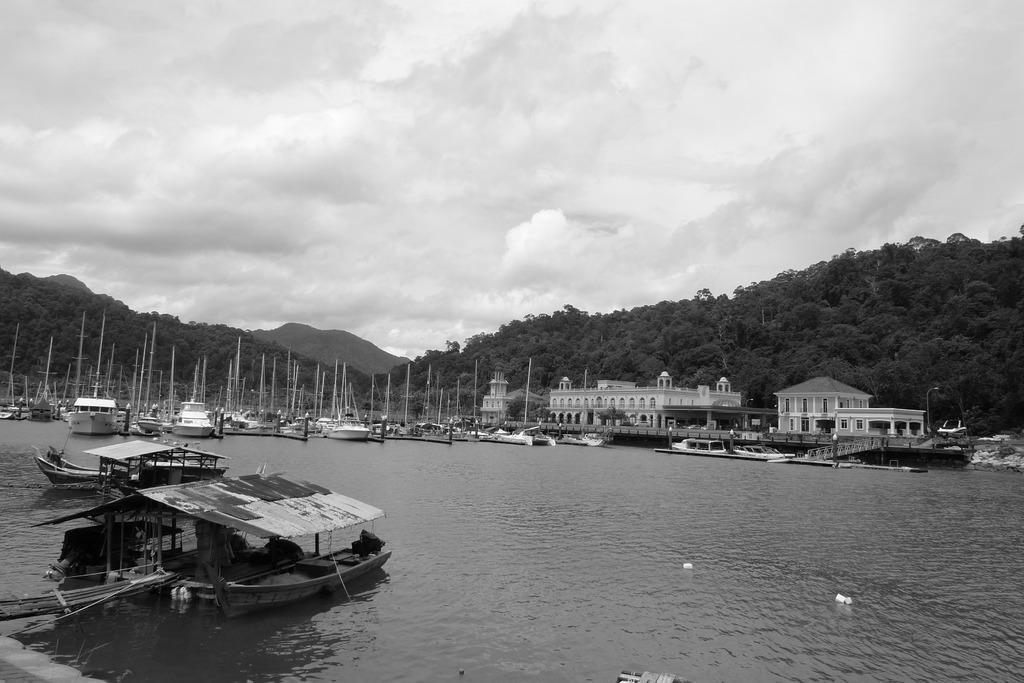In one or two sentences, can you explain what this image depicts? This image is a black and white image. This image is taken outdoors. At the top of the image there is the sky with clouds. At the bottom of the image there is a pond with water. In the background there are a few hills and there are many trees and plants. There is a building with wall, windows, doors, pillars and roof and there is a house. There is a bridge. There are many boats. There are many poles. 